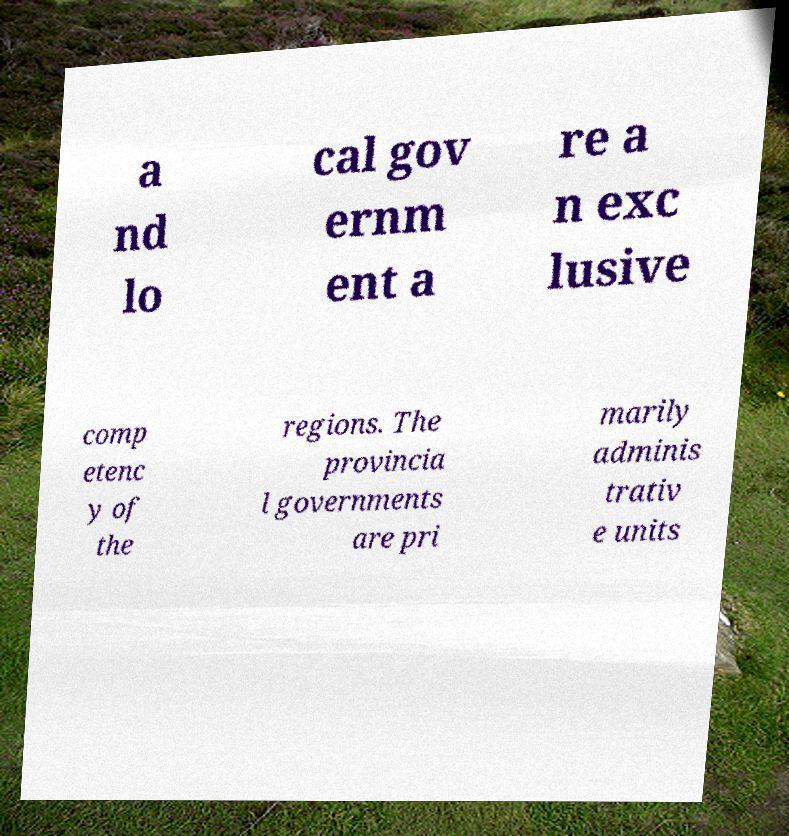I need the written content from this picture converted into text. Can you do that? a nd lo cal gov ernm ent a re a n exc lusive comp etenc y of the regions. The provincia l governments are pri marily adminis trativ e units 